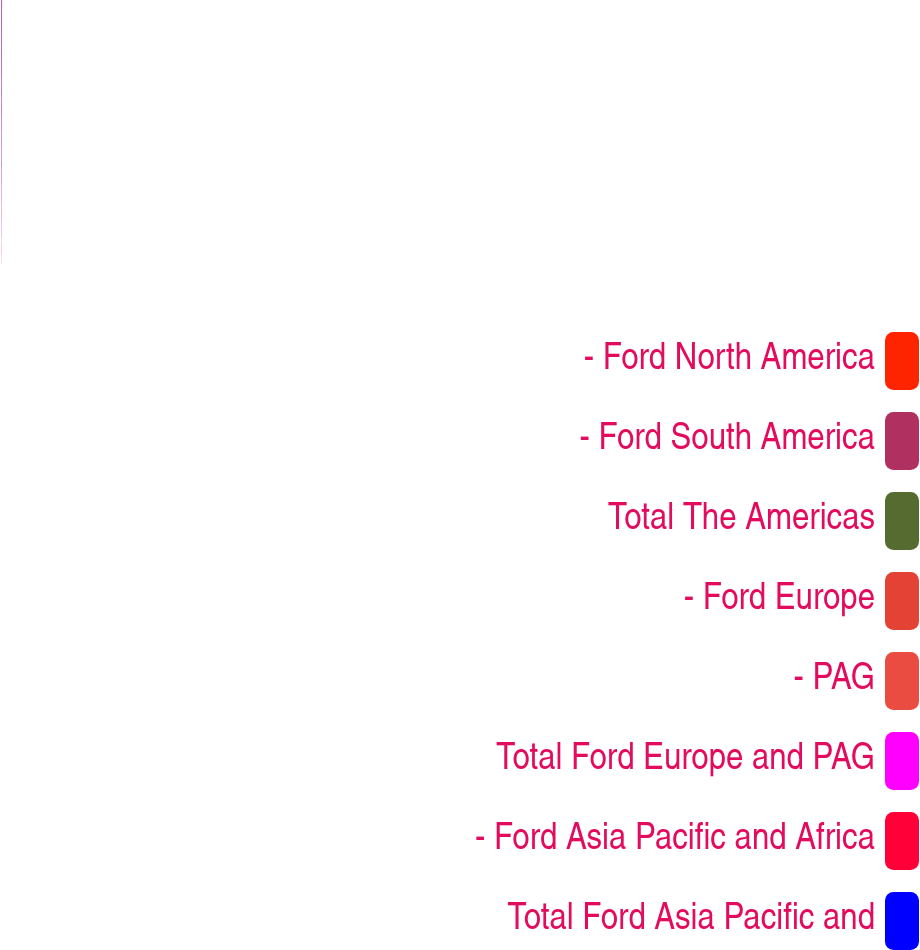<chart> <loc_0><loc_0><loc_500><loc_500><pie_chart><fcel>- Ford North America<fcel>- Ford South America<fcel>Total The Americas<fcel>- Ford Europe<fcel>- PAG<fcel>Total Ford Europe and PAG<fcel>- Ford Asia Pacific and Africa<fcel>Total Ford Asia Pacific and<nl><fcel>0.54%<fcel>31.4%<fcel>3.63%<fcel>12.89%<fcel>6.71%<fcel>9.8%<fcel>15.97%<fcel>19.06%<nl></chart> 